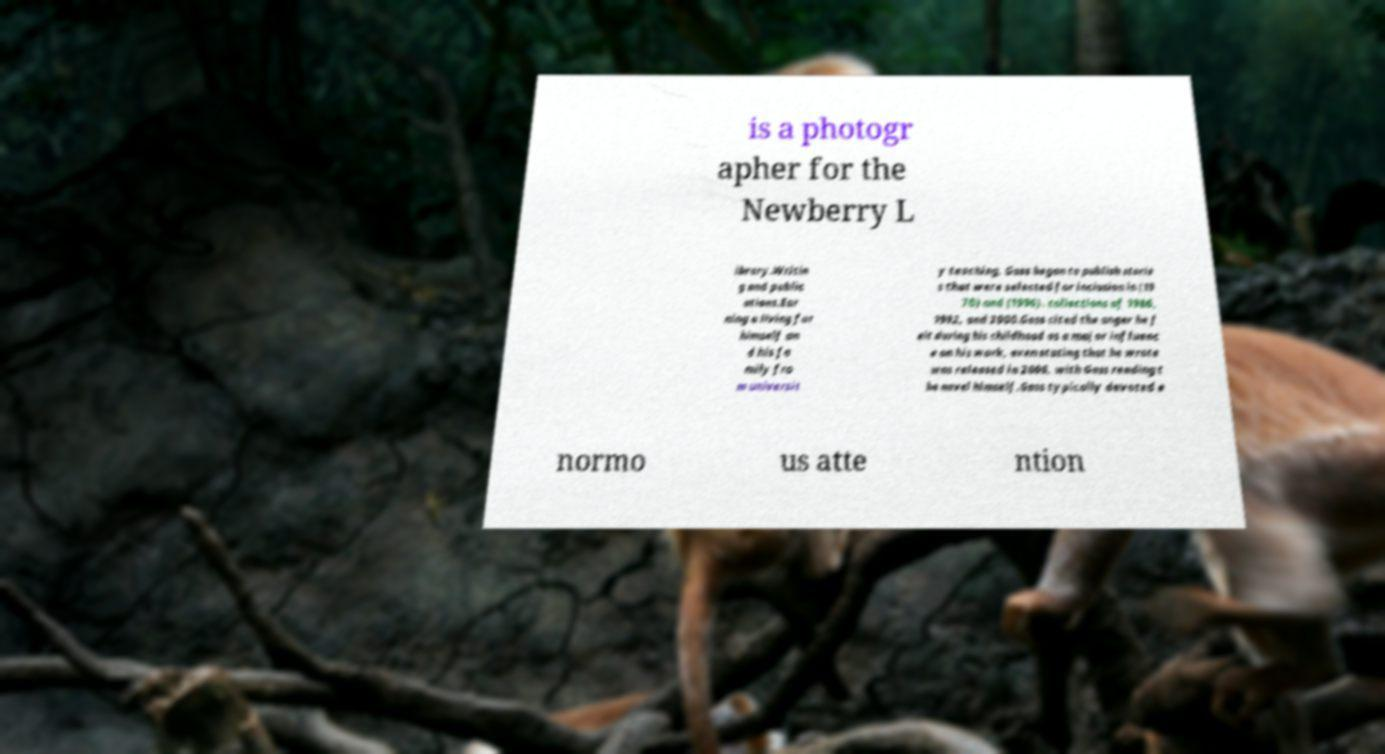Can you accurately transcribe the text from the provided image for me? is a photogr apher for the Newberry L ibrary.Writin g and public ations.Ear ning a living for himself an d his fa mily fro m universit y teaching, Gass began to publish storie s that were selected for inclusion in (19 70) and (1996). collections of 1986, 1992, and 2000.Gass cited the anger he f elt during his childhood as a major influenc e on his work, even stating that he wrote was released in 2006, with Gass reading t he novel himself.Gass typically devoted e normo us atte ntion 